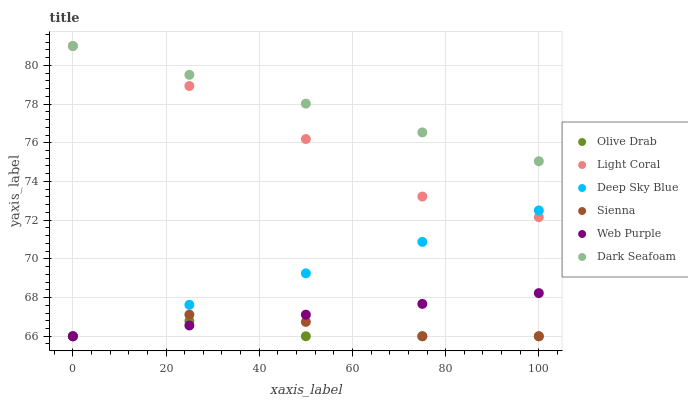Does Olive Drab have the minimum area under the curve?
Answer yes or no. Yes. Does Dark Seafoam have the maximum area under the curve?
Answer yes or no. Yes. Does Light Coral have the minimum area under the curve?
Answer yes or no. No. Does Light Coral have the maximum area under the curve?
Answer yes or no. No. Is Web Purple the smoothest?
Answer yes or no. Yes. Is Light Coral the roughest?
Answer yes or no. Yes. Is Dark Seafoam the smoothest?
Answer yes or no. No. Is Dark Seafoam the roughest?
Answer yes or no. No. Does Sienna have the lowest value?
Answer yes or no. Yes. Does Light Coral have the lowest value?
Answer yes or no. No. Does Light Coral have the highest value?
Answer yes or no. Yes. Does Web Purple have the highest value?
Answer yes or no. No. Is Sienna less than Dark Seafoam?
Answer yes or no. Yes. Is Dark Seafoam greater than Web Purple?
Answer yes or no. Yes. Does Web Purple intersect Deep Sky Blue?
Answer yes or no. Yes. Is Web Purple less than Deep Sky Blue?
Answer yes or no. No. Is Web Purple greater than Deep Sky Blue?
Answer yes or no. No. Does Sienna intersect Dark Seafoam?
Answer yes or no. No. 